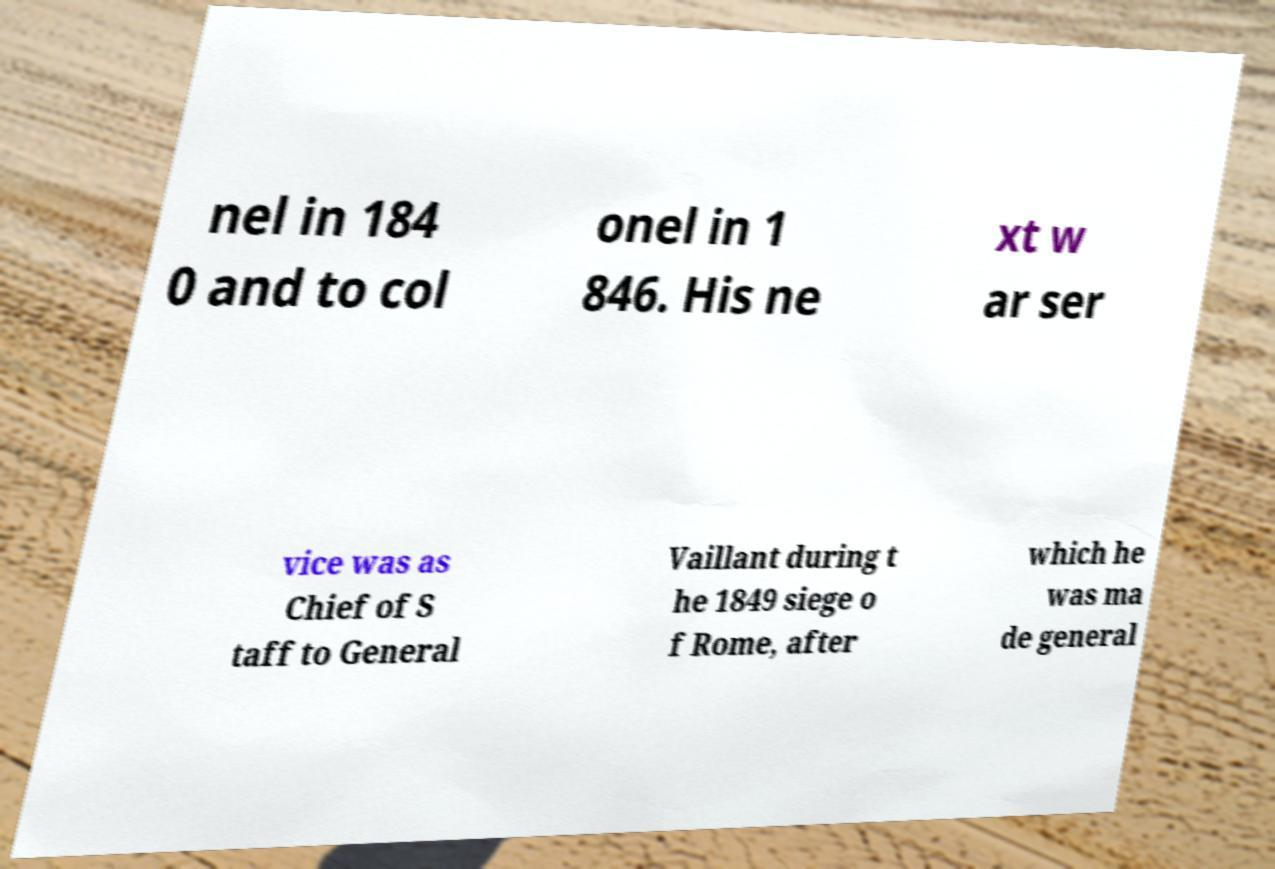I need the written content from this picture converted into text. Can you do that? nel in 184 0 and to col onel in 1 846. His ne xt w ar ser vice was as Chief of S taff to General Vaillant during t he 1849 siege o f Rome, after which he was ma de general 